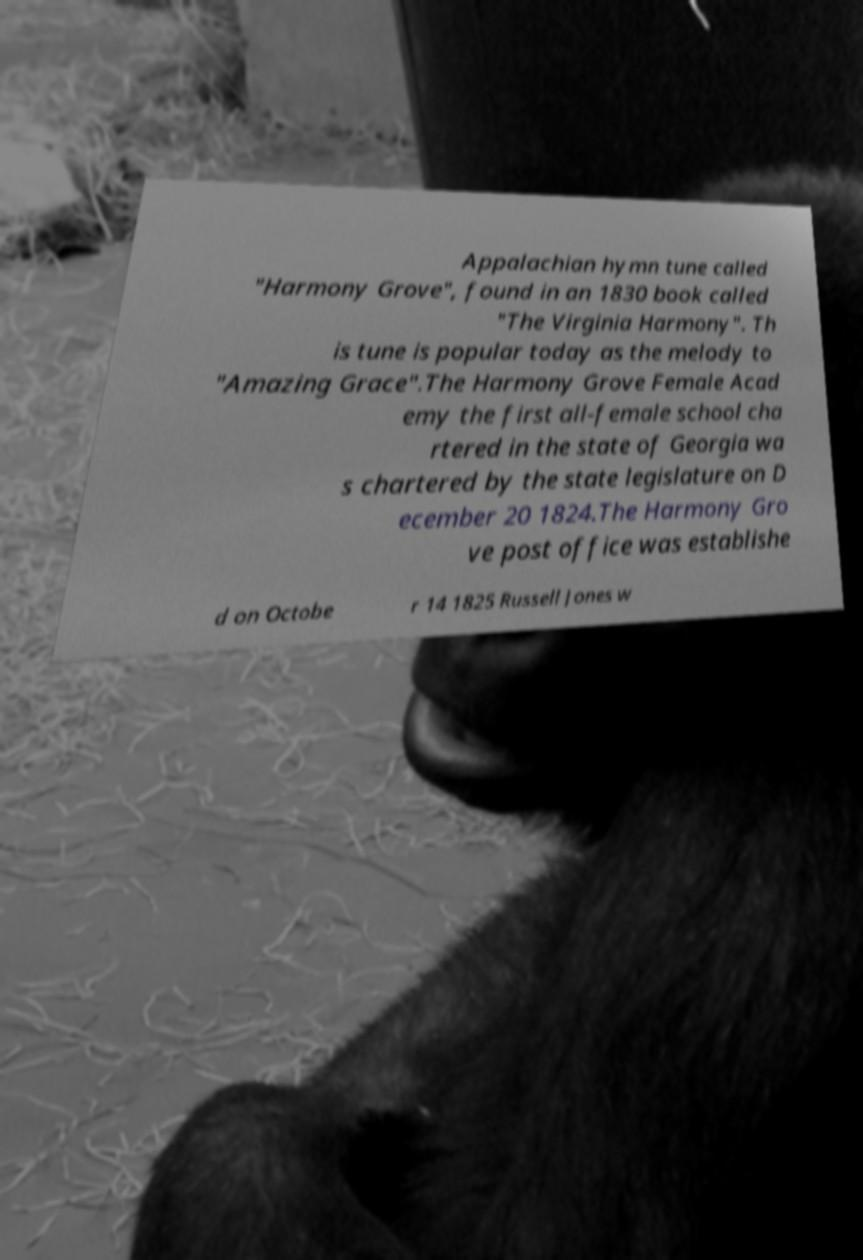Can you accurately transcribe the text from the provided image for me? Appalachian hymn tune called "Harmony Grove", found in an 1830 book called "The Virginia Harmony". Th is tune is popular today as the melody to "Amazing Grace".The Harmony Grove Female Acad emy the first all-female school cha rtered in the state of Georgia wa s chartered by the state legislature on D ecember 20 1824.The Harmony Gro ve post office was establishe d on Octobe r 14 1825 Russell Jones w 